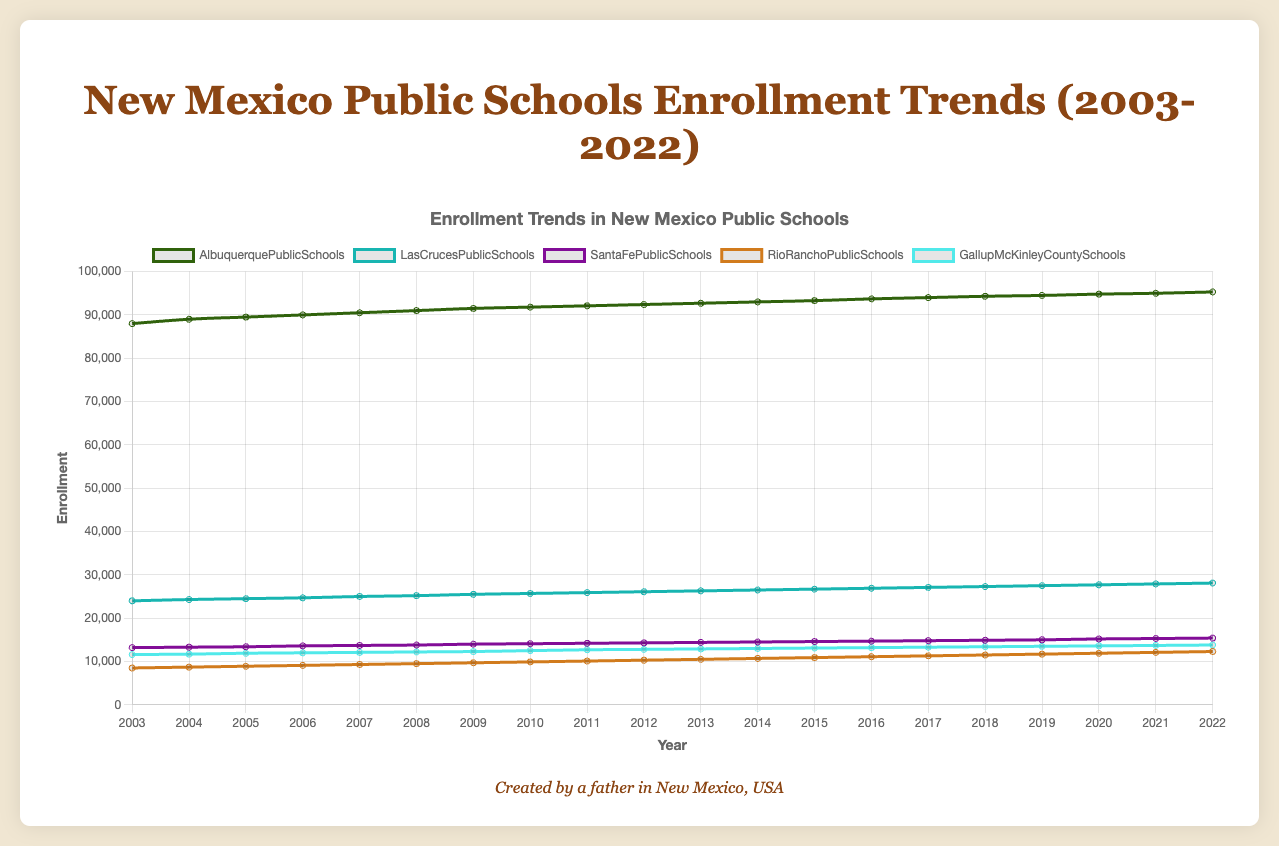Which school had the highest enrollment in 2022? In 2022, Albuquerque Public Schools had the highest enrollment. This can be seen by comparing the end points of each school's line on the plot and noting that Albuquerque Public Schools' line ends the highest.
Answer: Albuquerque Public Schools Between which years did Albuquerque Public Schools see the largest increase in enrollment? To find this, observe the steepness of the Albuquerque Public Schools line segment over the years. The steepest increase appears between 2003 (88000) and 2004 (89000), where the increase is 1000 students in one year.
Answer: Between 2003 and 2004 How did the enrollment trend of Rio Rancho Public Schools compare to that of Santa Fe Public Schools? Santa Fe Public Schools has a steady increase over the years, while Rio Rancho Public Schools also increases but at a slightly faster rate, especially noticeable from 2010 onwards as the gap between their lines widens.
Answer: Rio Rancho Public Schools grew faster On average, how much did Gallup-McKinley County Schools' enrollment increase per year? The enrollment for Gallup-McKinley County Schools in 2003 was 11600, and it increased to 13800 by 2022. So, the total increase over 19 years is 13800 - 11600 = 2200. Dividing this increase by the number of years (2200 ÷ 19) gives an average yearly increase.
Answer: About 115.8 per year Which school district showed the least variability in enrollment over the period? By examining the graph, Santa Fe Public Schools' line looks the least steep and most even, indicating it had the least variability in enrollment changes over the years.
Answer: Santa Fe Public Schools 